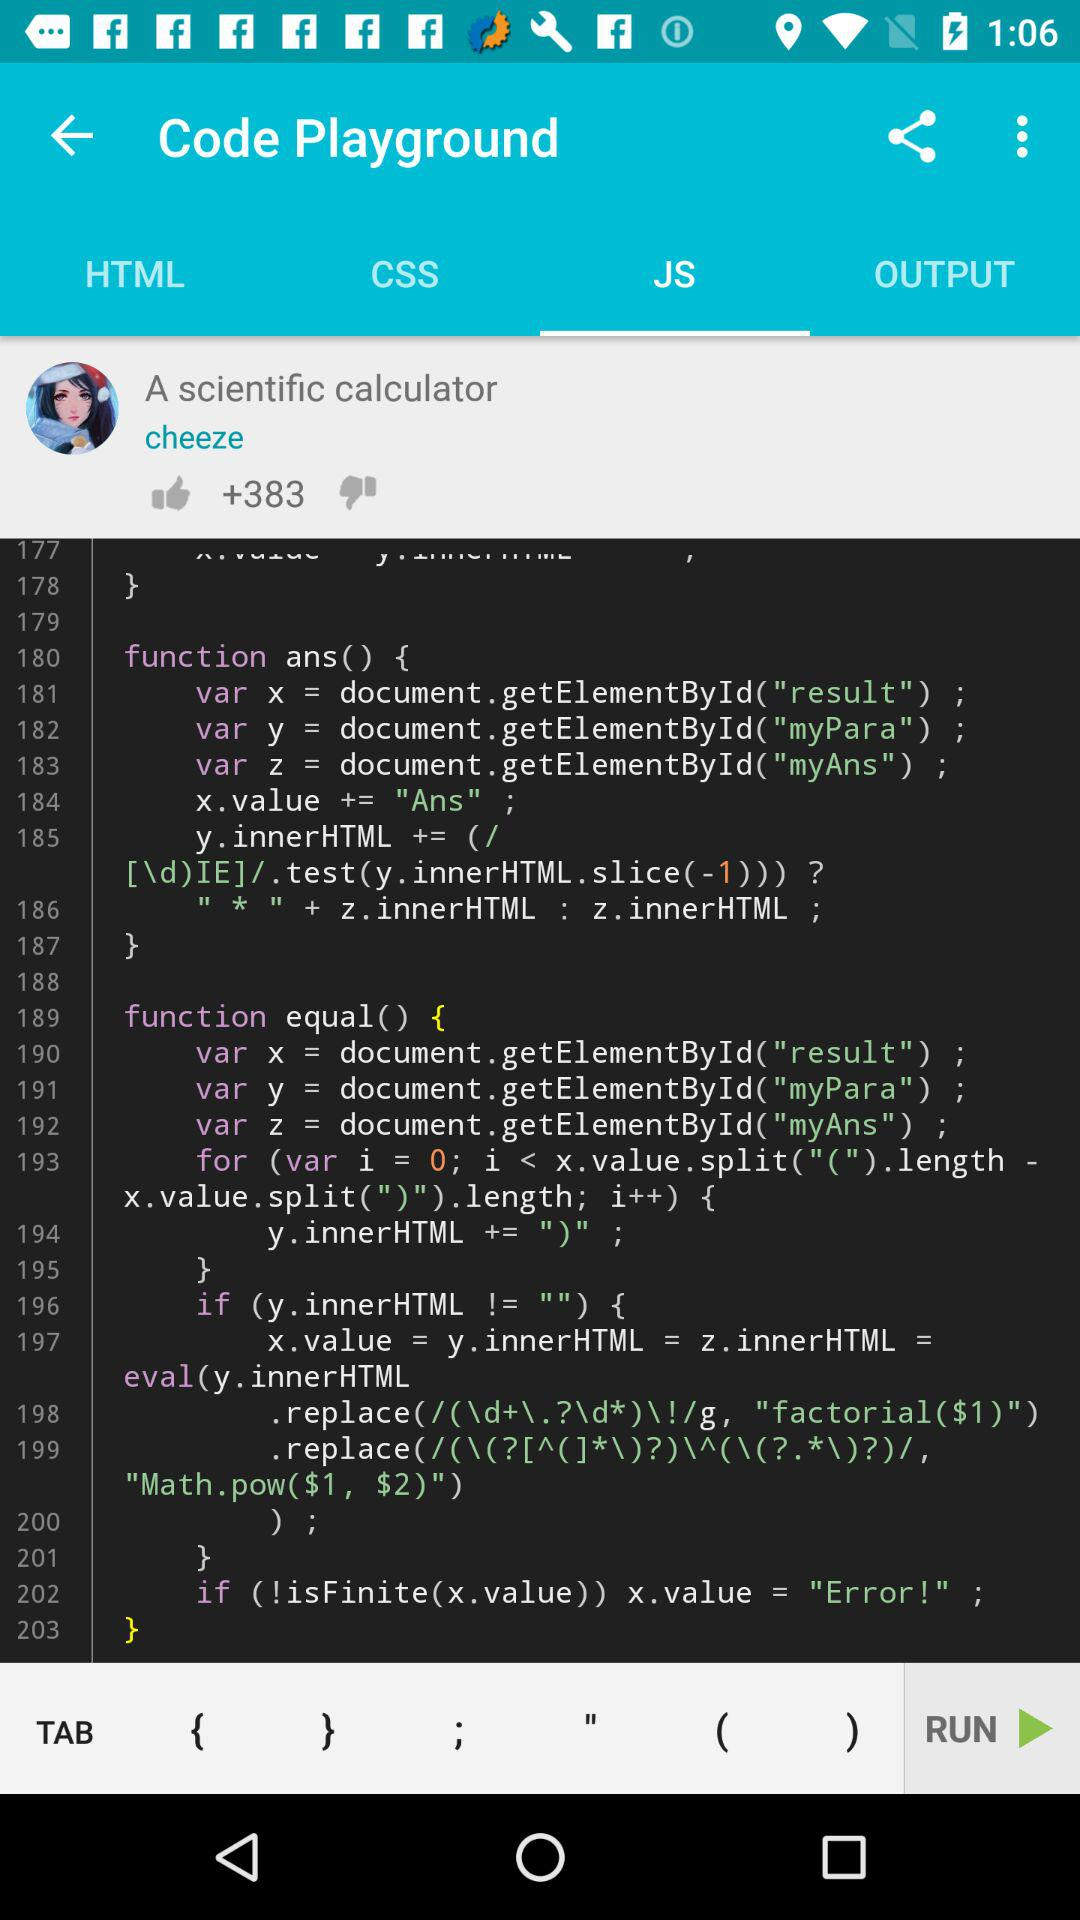How many likes are there? There are more than 383 likes. 